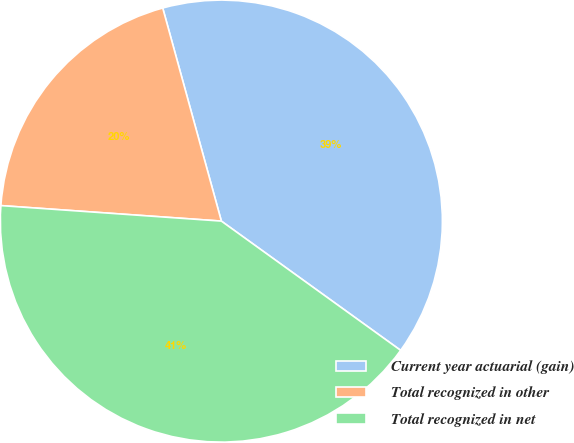Convert chart. <chart><loc_0><loc_0><loc_500><loc_500><pie_chart><fcel>Current year actuarial (gain)<fcel>Total recognized in other<fcel>Total recognized in net<nl><fcel>39.22%<fcel>19.61%<fcel>41.18%<nl></chart> 